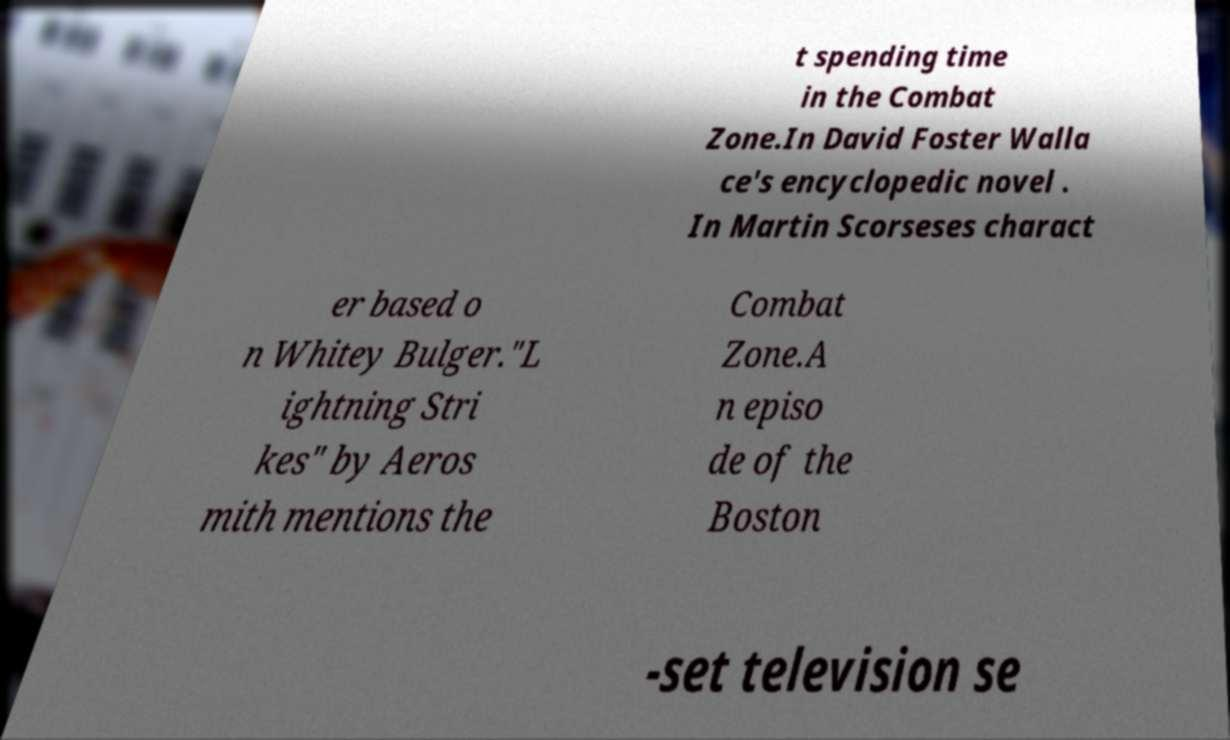For documentation purposes, I need the text within this image transcribed. Could you provide that? t spending time in the Combat Zone.In David Foster Walla ce's encyclopedic novel . In Martin Scorseses charact er based o n Whitey Bulger."L ightning Stri kes" by Aeros mith mentions the Combat Zone.A n episo de of the Boston -set television se 